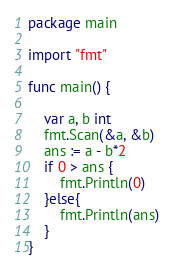<code> <loc_0><loc_0><loc_500><loc_500><_Go_>package main

import "fmt"

func main() {

	var a, b int
	fmt.Scan(&a, &b)
	ans := a - b*2
	if 0 > ans {
		fmt.Println(0)	
	}else{
		fmt.Println(ans)
	}
}</code> 